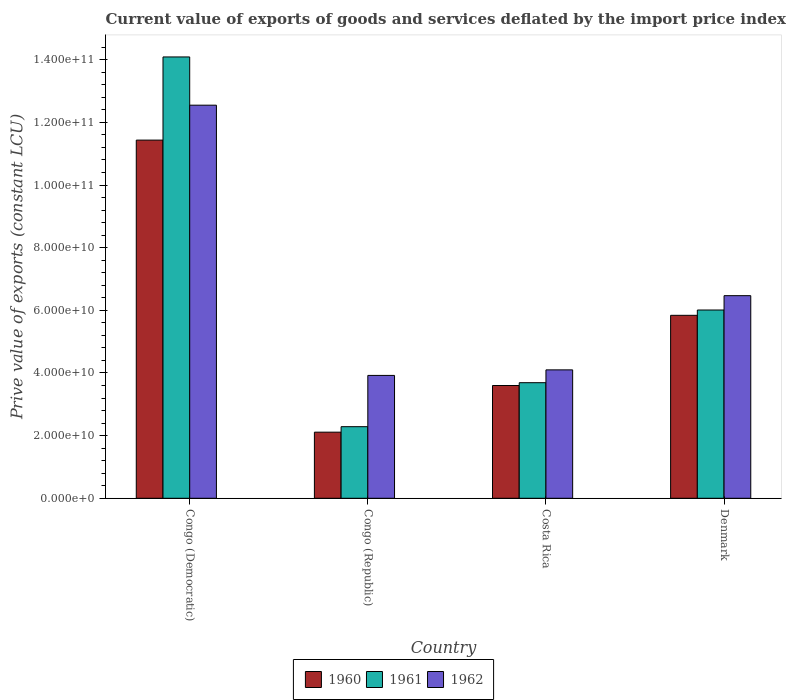Are the number of bars per tick equal to the number of legend labels?
Provide a succinct answer. Yes. Are the number of bars on each tick of the X-axis equal?
Offer a terse response. Yes. How many bars are there on the 2nd tick from the left?
Your response must be concise. 3. What is the prive value of exports in 1961 in Congo (Republic)?
Your answer should be compact. 2.29e+1. Across all countries, what is the maximum prive value of exports in 1962?
Your answer should be compact. 1.25e+11. Across all countries, what is the minimum prive value of exports in 1961?
Your response must be concise. 2.29e+1. In which country was the prive value of exports in 1962 maximum?
Provide a succinct answer. Congo (Democratic). In which country was the prive value of exports in 1961 minimum?
Make the answer very short. Congo (Republic). What is the total prive value of exports in 1962 in the graph?
Offer a terse response. 2.70e+11. What is the difference between the prive value of exports in 1962 in Congo (Democratic) and that in Denmark?
Your response must be concise. 6.08e+1. What is the difference between the prive value of exports in 1961 in Congo (Democratic) and the prive value of exports in 1960 in Costa Rica?
Give a very brief answer. 1.05e+11. What is the average prive value of exports in 1960 per country?
Ensure brevity in your answer.  5.75e+1. What is the difference between the prive value of exports of/in 1960 and prive value of exports of/in 1961 in Congo (Democratic)?
Ensure brevity in your answer.  -2.65e+1. In how many countries, is the prive value of exports in 1962 greater than 40000000000 LCU?
Make the answer very short. 3. What is the ratio of the prive value of exports in 1961 in Congo (Republic) to that in Denmark?
Your answer should be compact. 0.38. Is the difference between the prive value of exports in 1960 in Costa Rica and Denmark greater than the difference between the prive value of exports in 1961 in Costa Rica and Denmark?
Keep it short and to the point. Yes. What is the difference between the highest and the second highest prive value of exports in 1962?
Give a very brief answer. 2.37e+1. What is the difference between the highest and the lowest prive value of exports in 1960?
Offer a very short reply. 9.32e+1. What does the 1st bar from the right in Congo (Republic) represents?
Your answer should be very brief. 1962. Is it the case that in every country, the sum of the prive value of exports in 1962 and prive value of exports in 1960 is greater than the prive value of exports in 1961?
Offer a terse response. Yes. What is the difference between two consecutive major ticks on the Y-axis?
Your response must be concise. 2.00e+1. Does the graph contain any zero values?
Ensure brevity in your answer.  No. How many legend labels are there?
Give a very brief answer. 3. How are the legend labels stacked?
Make the answer very short. Horizontal. What is the title of the graph?
Your response must be concise. Current value of exports of goods and services deflated by the import price index. Does "1990" appear as one of the legend labels in the graph?
Offer a terse response. No. What is the label or title of the X-axis?
Your response must be concise. Country. What is the label or title of the Y-axis?
Offer a terse response. Prive value of exports (constant LCU). What is the Prive value of exports (constant LCU) in 1960 in Congo (Democratic)?
Provide a succinct answer. 1.14e+11. What is the Prive value of exports (constant LCU) of 1961 in Congo (Democratic)?
Provide a short and direct response. 1.41e+11. What is the Prive value of exports (constant LCU) of 1962 in Congo (Democratic)?
Offer a terse response. 1.25e+11. What is the Prive value of exports (constant LCU) of 1960 in Congo (Republic)?
Offer a very short reply. 2.11e+1. What is the Prive value of exports (constant LCU) in 1961 in Congo (Republic)?
Offer a terse response. 2.29e+1. What is the Prive value of exports (constant LCU) in 1962 in Congo (Republic)?
Give a very brief answer. 3.92e+1. What is the Prive value of exports (constant LCU) in 1960 in Costa Rica?
Your response must be concise. 3.60e+1. What is the Prive value of exports (constant LCU) in 1961 in Costa Rica?
Provide a short and direct response. 3.69e+1. What is the Prive value of exports (constant LCU) of 1962 in Costa Rica?
Offer a very short reply. 4.10e+1. What is the Prive value of exports (constant LCU) of 1960 in Denmark?
Your answer should be compact. 5.84e+1. What is the Prive value of exports (constant LCU) in 1961 in Denmark?
Provide a succinct answer. 6.01e+1. What is the Prive value of exports (constant LCU) of 1962 in Denmark?
Give a very brief answer. 6.47e+1. Across all countries, what is the maximum Prive value of exports (constant LCU) of 1960?
Keep it short and to the point. 1.14e+11. Across all countries, what is the maximum Prive value of exports (constant LCU) in 1961?
Offer a very short reply. 1.41e+11. Across all countries, what is the maximum Prive value of exports (constant LCU) of 1962?
Provide a succinct answer. 1.25e+11. Across all countries, what is the minimum Prive value of exports (constant LCU) in 1960?
Your response must be concise. 2.11e+1. Across all countries, what is the minimum Prive value of exports (constant LCU) in 1961?
Provide a short and direct response. 2.29e+1. Across all countries, what is the minimum Prive value of exports (constant LCU) of 1962?
Your answer should be very brief. 3.92e+1. What is the total Prive value of exports (constant LCU) of 1960 in the graph?
Ensure brevity in your answer.  2.30e+11. What is the total Prive value of exports (constant LCU) in 1961 in the graph?
Your answer should be compact. 2.61e+11. What is the total Prive value of exports (constant LCU) in 1962 in the graph?
Your answer should be compact. 2.70e+11. What is the difference between the Prive value of exports (constant LCU) of 1960 in Congo (Democratic) and that in Congo (Republic)?
Make the answer very short. 9.32e+1. What is the difference between the Prive value of exports (constant LCU) in 1961 in Congo (Democratic) and that in Congo (Republic)?
Your answer should be compact. 1.18e+11. What is the difference between the Prive value of exports (constant LCU) in 1962 in Congo (Democratic) and that in Congo (Republic)?
Your response must be concise. 8.63e+1. What is the difference between the Prive value of exports (constant LCU) of 1960 in Congo (Democratic) and that in Costa Rica?
Give a very brief answer. 7.83e+1. What is the difference between the Prive value of exports (constant LCU) of 1961 in Congo (Democratic) and that in Costa Rica?
Offer a very short reply. 1.04e+11. What is the difference between the Prive value of exports (constant LCU) of 1962 in Congo (Democratic) and that in Costa Rica?
Provide a succinct answer. 8.45e+1. What is the difference between the Prive value of exports (constant LCU) in 1960 in Congo (Democratic) and that in Denmark?
Give a very brief answer. 5.59e+1. What is the difference between the Prive value of exports (constant LCU) in 1961 in Congo (Democratic) and that in Denmark?
Offer a terse response. 8.08e+1. What is the difference between the Prive value of exports (constant LCU) in 1962 in Congo (Democratic) and that in Denmark?
Your answer should be compact. 6.08e+1. What is the difference between the Prive value of exports (constant LCU) of 1960 in Congo (Republic) and that in Costa Rica?
Keep it short and to the point. -1.49e+1. What is the difference between the Prive value of exports (constant LCU) in 1961 in Congo (Republic) and that in Costa Rica?
Keep it short and to the point. -1.40e+1. What is the difference between the Prive value of exports (constant LCU) of 1962 in Congo (Republic) and that in Costa Rica?
Your response must be concise. -1.77e+09. What is the difference between the Prive value of exports (constant LCU) in 1960 in Congo (Republic) and that in Denmark?
Ensure brevity in your answer.  -3.73e+1. What is the difference between the Prive value of exports (constant LCU) of 1961 in Congo (Republic) and that in Denmark?
Give a very brief answer. -3.72e+1. What is the difference between the Prive value of exports (constant LCU) in 1962 in Congo (Republic) and that in Denmark?
Offer a very short reply. -2.55e+1. What is the difference between the Prive value of exports (constant LCU) in 1960 in Costa Rica and that in Denmark?
Give a very brief answer. -2.24e+1. What is the difference between the Prive value of exports (constant LCU) in 1961 in Costa Rica and that in Denmark?
Ensure brevity in your answer.  -2.32e+1. What is the difference between the Prive value of exports (constant LCU) in 1962 in Costa Rica and that in Denmark?
Your response must be concise. -2.37e+1. What is the difference between the Prive value of exports (constant LCU) in 1960 in Congo (Democratic) and the Prive value of exports (constant LCU) in 1961 in Congo (Republic)?
Your response must be concise. 9.15e+1. What is the difference between the Prive value of exports (constant LCU) in 1960 in Congo (Democratic) and the Prive value of exports (constant LCU) in 1962 in Congo (Republic)?
Give a very brief answer. 7.51e+1. What is the difference between the Prive value of exports (constant LCU) in 1961 in Congo (Democratic) and the Prive value of exports (constant LCU) in 1962 in Congo (Republic)?
Provide a short and direct response. 1.02e+11. What is the difference between the Prive value of exports (constant LCU) in 1960 in Congo (Democratic) and the Prive value of exports (constant LCU) in 1961 in Costa Rica?
Your response must be concise. 7.74e+1. What is the difference between the Prive value of exports (constant LCU) of 1960 in Congo (Democratic) and the Prive value of exports (constant LCU) of 1962 in Costa Rica?
Provide a short and direct response. 7.33e+1. What is the difference between the Prive value of exports (constant LCU) in 1961 in Congo (Democratic) and the Prive value of exports (constant LCU) in 1962 in Costa Rica?
Make the answer very short. 9.99e+1. What is the difference between the Prive value of exports (constant LCU) of 1960 in Congo (Democratic) and the Prive value of exports (constant LCU) of 1961 in Denmark?
Ensure brevity in your answer.  5.42e+1. What is the difference between the Prive value of exports (constant LCU) of 1960 in Congo (Democratic) and the Prive value of exports (constant LCU) of 1962 in Denmark?
Give a very brief answer. 4.97e+1. What is the difference between the Prive value of exports (constant LCU) of 1961 in Congo (Democratic) and the Prive value of exports (constant LCU) of 1962 in Denmark?
Make the answer very short. 7.62e+1. What is the difference between the Prive value of exports (constant LCU) of 1960 in Congo (Republic) and the Prive value of exports (constant LCU) of 1961 in Costa Rica?
Make the answer very short. -1.58e+1. What is the difference between the Prive value of exports (constant LCU) in 1960 in Congo (Republic) and the Prive value of exports (constant LCU) in 1962 in Costa Rica?
Your answer should be compact. -1.99e+1. What is the difference between the Prive value of exports (constant LCU) of 1961 in Congo (Republic) and the Prive value of exports (constant LCU) of 1962 in Costa Rica?
Give a very brief answer. -1.81e+1. What is the difference between the Prive value of exports (constant LCU) of 1960 in Congo (Republic) and the Prive value of exports (constant LCU) of 1961 in Denmark?
Make the answer very short. -3.90e+1. What is the difference between the Prive value of exports (constant LCU) in 1960 in Congo (Republic) and the Prive value of exports (constant LCU) in 1962 in Denmark?
Your response must be concise. -4.36e+1. What is the difference between the Prive value of exports (constant LCU) of 1961 in Congo (Republic) and the Prive value of exports (constant LCU) of 1962 in Denmark?
Offer a very short reply. -4.18e+1. What is the difference between the Prive value of exports (constant LCU) in 1960 in Costa Rica and the Prive value of exports (constant LCU) in 1961 in Denmark?
Keep it short and to the point. -2.41e+1. What is the difference between the Prive value of exports (constant LCU) of 1960 in Costa Rica and the Prive value of exports (constant LCU) of 1962 in Denmark?
Keep it short and to the point. -2.87e+1. What is the difference between the Prive value of exports (constant LCU) of 1961 in Costa Rica and the Prive value of exports (constant LCU) of 1962 in Denmark?
Your answer should be compact. -2.78e+1. What is the average Prive value of exports (constant LCU) in 1960 per country?
Offer a terse response. 5.75e+1. What is the average Prive value of exports (constant LCU) of 1961 per country?
Provide a short and direct response. 6.52e+1. What is the average Prive value of exports (constant LCU) of 1962 per country?
Your answer should be compact. 6.76e+1. What is the difference between the Prive value of exports (constant LCU) in 1960 and Prive value of exports (constant LCU) in 1961 in Congo (Democratic)?
Your response must be concise. -2.65e+1. What is the difference between the Prive value of exports (constant LCU) in 1960 and Prive value of exports (constant LCU) in 1962 in Congo (Democratic)?
Keep it short and to the point. -1.11e+1. What is the difference between the Prive value of exports (constant LCU) in 1961 and Prive value of exports (constant LCU) in 1962 in Congo (Democratic)?
Give a very brief answer. 1.54e+1. What is the difference between the Prive value of exports (constant LCU) of 1960 and Prive value of exports (constant LCU) of 1961 in Congo (Republic)?
Your response must be concise. -1.75e+09. What is the difference between the Prive value of exports (constant LCU) in 1960 and Prive value of exports (constant LCU) in 1962 in Congo (Republic)?
Provide a succinct answer. -1.81e+1. What is the difference between the Prive value of exports (constant LCU) in 1961 and Prive value of exports (constant LCU) in 1962 in Congo (Republic)?
Give a very brief answer. -1.64e+1. What is the difference between the Prive value of exports (constant LCU) of 1960 and Prive value of exports (constant LCU) of 1961 in Costa Rica?
Provide a succinct answer. -8.99e+08. What is the difference between the Prive value of exports (constant LCU) of 1960 and Prive value of exports (constant LCU) of 1962 in Costa Rica?
Give a very brief answer. -4.99e+09. What is the difference between the Prive value of exports (constant LCU) of 1961 and Prive value of exports (constant LCU) of 1962 in Costa Rica?
Your answer should be compact. -4.09e+09. What is the difference between the Prive value of exports (constant LCU) of 1960 and Prive value of exports (constant LCU) of 1961 in Denmark?
Offer a very short reply. -1.70e+09. What is the difference between the Prive value of exports (constant LCU) of 1960 and Prive value of exports (constant LCU) of 1962 in Denmark?
Ensure brevity in your answer.  -6.28e+09. What is the difference between the Prive value of exports (constant LCU) of 1961 and Prive value of exports (constant LCU) of 1962 in Denmark?
Provide a succinct answer. -4.58e+09. What is the ratio of the Prive value of exports (constant LCU) in 1960 in Congo (Democratic) to that in Congo (Republic)?
Provide a succinct answer. 5.42. What is the ratio of the Prive value of exports (constant LCU) of 1961 in Congo (Democratic) to that in Congo (Republic)?
Give a very brief answer. 6.16. What is the ratio of the Prive value of exports (constant LCU) in 1962 in Congo (Democratic) to that in Congo (Republic)?
Provide a short and direct response. 3.2. What is the ratio of the Prive value of exports (constant LCU) of 1960 in Congo (Democratic) to that in Costa Rica?
Give a very brief answer. 3.18. What is the ratio of the Prive value of exports (constant LCU) in 1961 in Congo (Democratic) to that in Costa Rica?
Your answer should be compact. 3.82. What is the ratio of the Prive value of exports (constant LCU) of 1962 in Congo (Democratic) to that in Costa Rica?
Give a very brief answer. 3.06. What is the ratio of the Prive value of exports (constant LCU) of 1960 in Congo (Democratic) to that in Denmark?
Offer a very short reply. 1.96. What is the ratio of the Prive value of exports (constant LCU) of 1961 in Congo (Democratic) to that in Denmark?
Offer a terse response. 2.34. What is the ratio of the Prive value of exports (constant LCU) in 1962 in Congo (Democratic) to that in Denmark?
Your answer should be compact. 1.94. What is the ratio of the Prive value of exports (constant LCU) of 1960 in Congo (Republic) to that in Costa Rica?
Make the answer very short. 0.59. What is the ratio of the Prive value of exports (constant LCU) in 1961 in Congo (Republic) to that in Costa Rica?
Make the answer very short. 0.62. What is the ratio of the Prive value of exports (constant LCU) in 1962 in Congo (Republic) to that in Costa Rica?
Your answer should be compact. 0.96. What is the ratio of the Prive value of exports (constant LCU) in 1960 in Congo (Republic) to that in Denmark?
Ensure brevity in your answer.  0.36. What is the ratio of the Prive value of exports (constant LCU) in 1961 in Congo (Republic) to that in Denmark?
Your answer should be very brief. 0.38. What is the ratio of the Prive value of exports (constant LCU) of 1962 in Congo (Republic) to that in Denmark?
Your answer should be very brief. 0.61. What is the ratio of the Prive value of exports (constant LCU) of 1960 in Costa Rica to that in Denmark?
Provide a short and direct response. 0.62. What is the ratio of the Prive value of exports (constant LCU) in 1961 in Costa Rica to that in Denmark?
Keep it short and to the point. 0.61. What is the ratio of the Prive value of exports (constant LCU) of 1962 in Costa Rica to that in Denmark?
Keep it short and to the point. 0.63. What is the difference between the highest and the second highest Prive value of exports (constant LCU) of 1960?
Keep it short and to the point. 5.59e+1. What is the difference between the highest and the second highest Prive value of exports (constant LCU) of 1961?
Offer a terse response. 8.08e+1. What is the difference between the highest and the second highest Prive value of exports (constant LCU) in 1962?
Your answer should be very brief. 6.08e+1. What is the difference between the highest and the lowest Prive value of exports (constant LCU) in 1960?
Your response must be concise. 9.32e+1. What is the difference between the highest and the lowest Prive value of exports (constant LCU) of 1961?
Your answer should be very brief. 1.18e+11. What is the difference between the highest and the lowest Prive value of exports (constant LCU) in 1962?
Make the answer very short. 8.63e+1. 